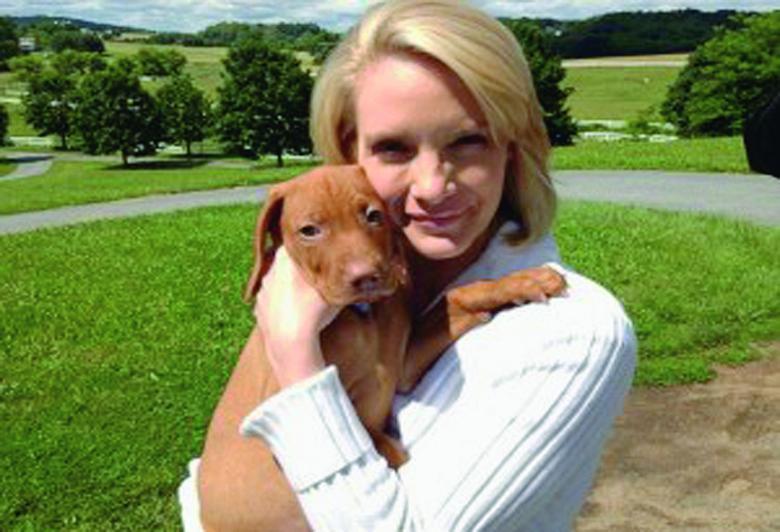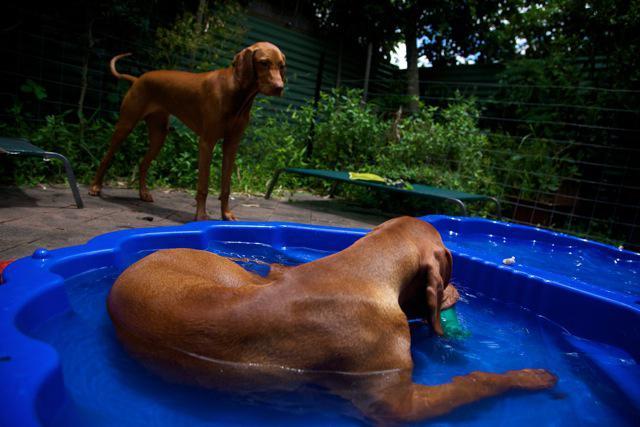The first image is the image on the left, the second image is the image on the right. Considering the images on both sides, is "A dog is leaping into the pool" valid? Answer yes or no. No. The first image is the image on the left, the second image is the image on the right. Given the left and right images, does the statement "One of the dogs is on a blue floating raft and looking to the right." hold true? Answer yes or no. No. 